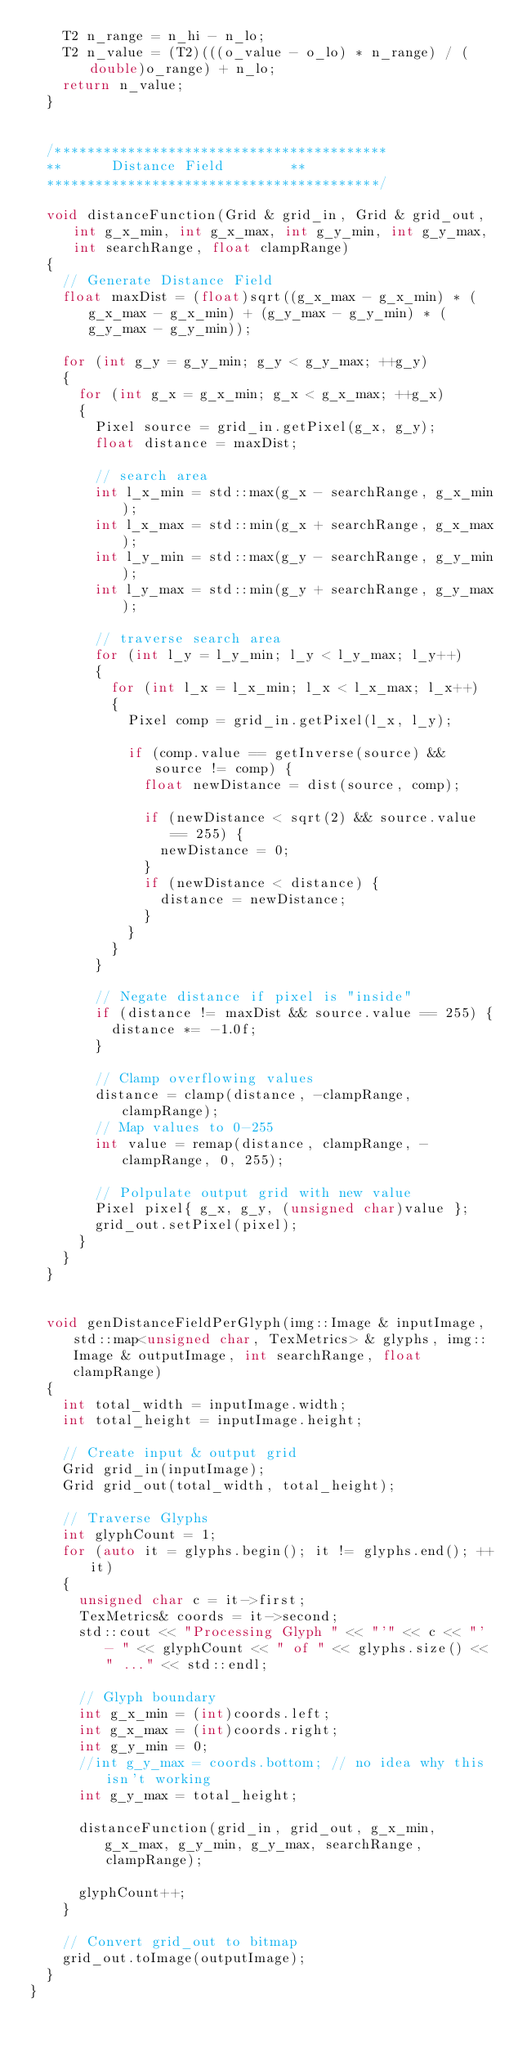<code> <loc_0><loc_0><loc_500><loc_500><_C++_>		T2 n_range = n_hi - n_lo;
		T2 n_value = (T2)(((o_value - o_lo) * n_range) / (double)o_range) + n_lo;
		return n_value;
	}


	/*****************************************
	**			Distance Field 				**
	*****************************************/

	void distanceFunction(Grid & grid_in, Grid & grid_out, int g_x_min, int g_x_max, int g_y_min, int g_y_max, int searchRange, float clampRange)
	{
		// Generate Distance Field
		float maxDist = (float)sqrt((g_x_max - g_x_min) * (g_x_max - g_x_min) + (g_y_max - g_y_min) * (g_y_max - g_y_min));

		for (int g_y = g_y_min; g_y < g_y_max; ++g_y)
		{
			for (int g_x = g_x_min; g_x < g_x_max; ++g_x)
			{
				Pixel source = grid_in.getPixel(g_x, g_y);
				float distance = maxDist;

				// search area
				int l_x_min = std::max(g_x - searchRange, g_x_min);
				int l_x_max = std::min(g_x + searchRange, g_x_max);
				int l_y_min = std::max(g_y - searchRange, g_y_min);
				int l_y_max = std::min(g_y + searchRange, g_y_max);

				// traverse search area
				for (int l_y = l_y_min; l_y < l_y_max; l_y++)
				{
					for (int l_x = l_x_min; l_x < l_x_max; l_x++)
					{
						Pixel comp = grid_in.getPixel(l_x, l_y);

						if (comp.value == getInverse(source) && source != comp) {
							float newDistance = dist(source, comp);

							if (newDistance < sqrt(2) && source.value == 255) {
								newDistance = 0;
							}
							if (newDistance < distance) {
								distance = newDistance;
							}
						}
					}
				}

				// Negate distance if pixel is "inside"
				if (distance != maxDist && source.value == 255) {
					distance *= -1.0f;
				}

				// Clamp overflowing values
				distance = clamp(distance, -clampRange, clampRange);
				// Map values to 0-255
				int value = remap(distance, clampRange, -clampRange, 0, 255);

				// Polpulate output grid with new value
				Pixel pixel{ g_x, g_y, (unsigned char)value };
				grid_out.setPixel(pixel);
			}
		}
	}


	void genDistanceFieldPerGlyph(img::Image & inputImage, std::map<unsigned char, TexMetrics> & glyphs, img::Image & outputImage, int searchRange, float clampRange)
	{
		int total_width = inputImage.width;
		int total_height = inputImage.height;

		// Create input & output grid
		Grid grid_in(inputImage);
		Grid grid_out(total_width, total_height);

		// Traverse Glyphs
		int glyphCount = 1;
		for (auto it = glyphs.begin(); it != glyphs.end(); ++it)
		{
			unsigned char c = it->first;
			TexMetrics& coords = it->second;
			std::cout << "Processing Glyph " << "'" << c << "' - " << glyphCount << " of " << glyphs.size() << " ..." << std::endl;

			// Glyph boundary
			int g_x_min = (int)coords.left;
			int g_x_max = (int)coords.right;
			int g_y_min = 0;
			//int g_y_max = coords.bottom; // no idea why this isn't working
			int g_y_max = total_height;

			distanceFunction(grid_in, grid_out, g_x_min, g_x_max, g_y_min, g_y_max, searchRange, clampRange);

			glyphCount++;
		}

		// Convert grid_out to bitmap
		grid_out.toImage(outputImage);
	}
}</code> 